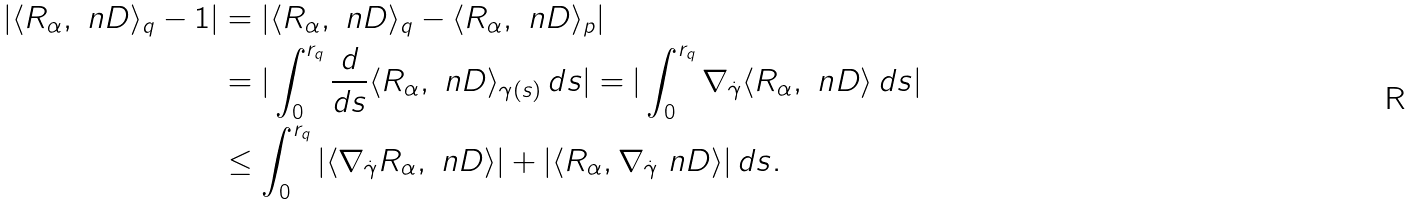<formula> <loc_0><loc_0><loc_500><loc_500>| \langle R _ { \alpha } , \ n D \rangle _ { q } - 1 | & = | \langle R _ { \alpha } , \ n D \rangle _ { q } - \langle R _ { \alpha } , \ n D \rangle _ { p } | \\ & = | \int _ { 0 } ^ { r _ { q } } \frac { d } { d s } \langle R _ { \alpha } , \ n D \rangle _ { \gamma ( s ) } \, d s | = | \int ^ { r _ { q } } _ { 0 } \nabla _ { \dot { \gamma } } \langle R _ { \alpha } , \ n D \rangle \, d s | \\ & \leq \int ^ { r _ { q } } _ { 0 } | \langle \nabla _ { \dot { \gamma } } R _ { \alpha } , \ n D \rangle | + | \langle R _ { \alpha } , \nabla _ { \dot { \gamma } } \ n D \rangle | \, d s .</formula> 